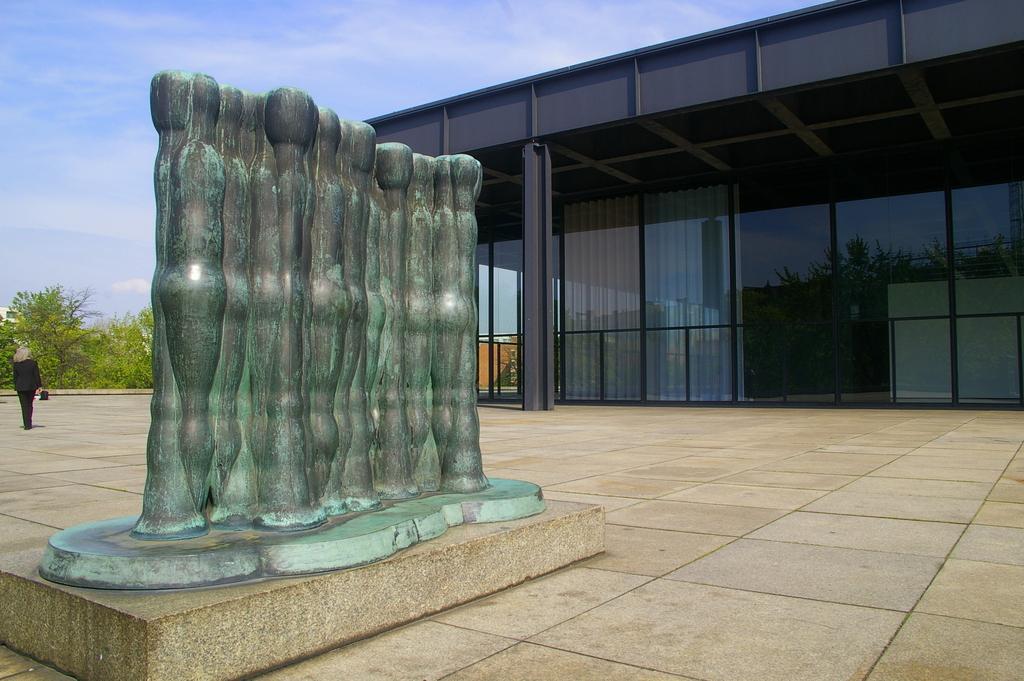In one or two sentences, can you explain what this image depicts? In this image we can see some structure on the path. We can also see the building with glass windows. On the left, we can see a person walking on the path. We can also see the trees. In the background there is sky. 